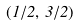<formula> <loc_0><loc_0><loc_500><loc_500>( 1 / 2 , \, 3 / 2 )</formula> 